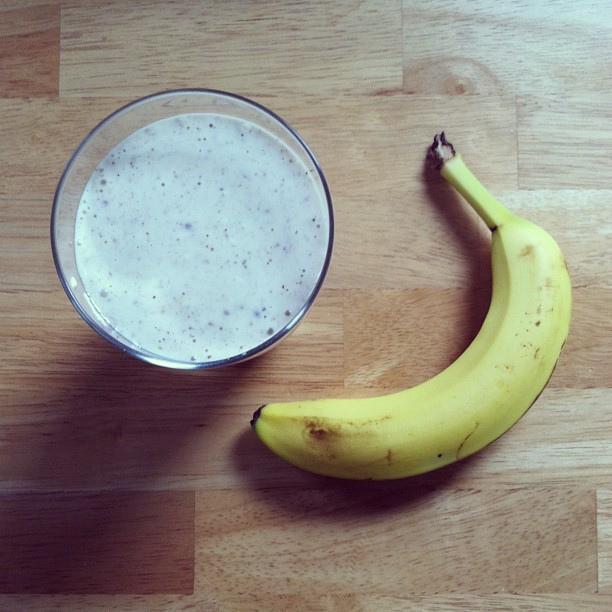Does the image validate the caption "The bowl contains the banana."?
Answer yes or no. No. Is the statement "The banana is in the middle of the dining table." accurate regarding the image?
Answer yes or no. No. Is the given caption "The banana is in the bowl." fitting for the image?
Answer yes or no. No. Is this affirmation: "The bowl is at the left side of the banana." correct?
Answer yes or no. Yes. 